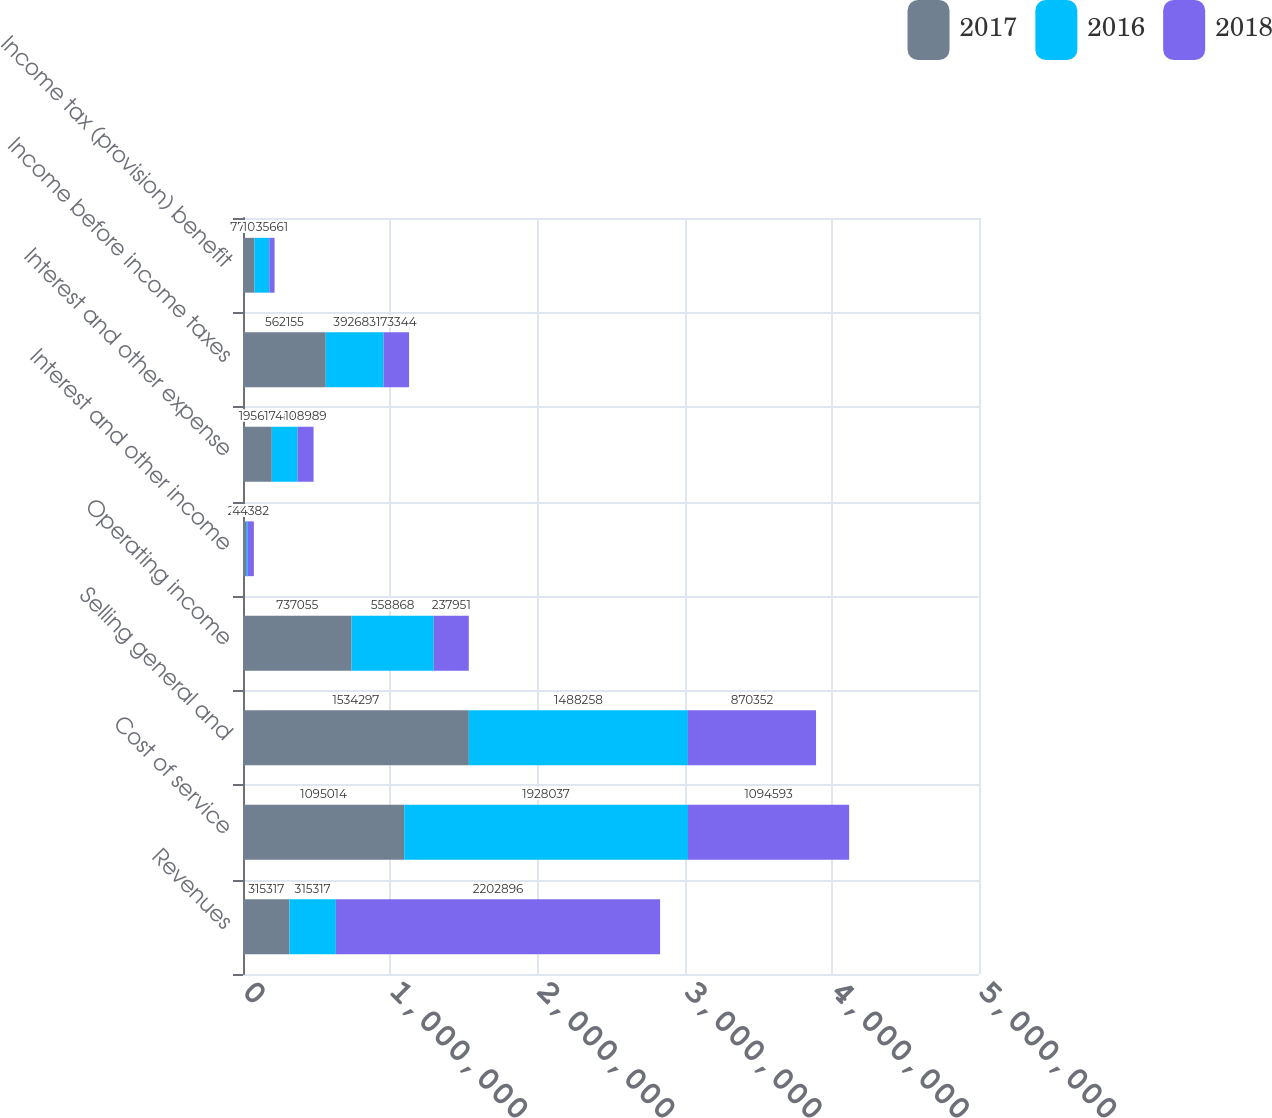Convert chart. <chart><loc_0><loc_0><loc_500><loc_500><stacked_bar_chart><ecel><fcel>Revenues<fcel>Cost of service<fcel>Selling general and<fcel>Operating income<fcel>Interest and other income<fcel>Interest and other expense<fcel>Income before income taxes<fcel>Income tax (provision) benefit<nl><fcel>2017<fcel>315317<fcel>1.09501e+06<fcel>1.5343e+06<fcel>737055<fcel>20719<fcel>195619<fcel>562155<fcel>77488<nl><fcel>2016<fcel>315317<fcel>1.92804e+06<fcel>1.48826e+06<fcel>558868<fcel>8662<fcel>174847<fcel>392683<fcel>101387<nl><fcel>2018<fcel>2.2029e+06<fcel>1.09459e+06<fcel>870352<fcel>237951<fcel>44382<fcel>108989<fcel>173344<fcel>35661<nl></chart> 